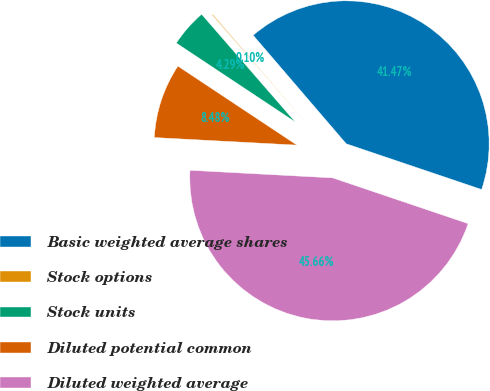Convert chart. <chart><loc_0><loc_0><loc_500><loc_500><pie_chart><fcel>Basic weighted average shares<fcel>Stock options<fcel>Stock units<fcel>Diluted potential common<fcel>Diluted weighted average<nl><fcel>41.47%<fcel>0.1%<fcel>4.29%<fcel>8.48%<fcel>45.66%<nl></chart> 